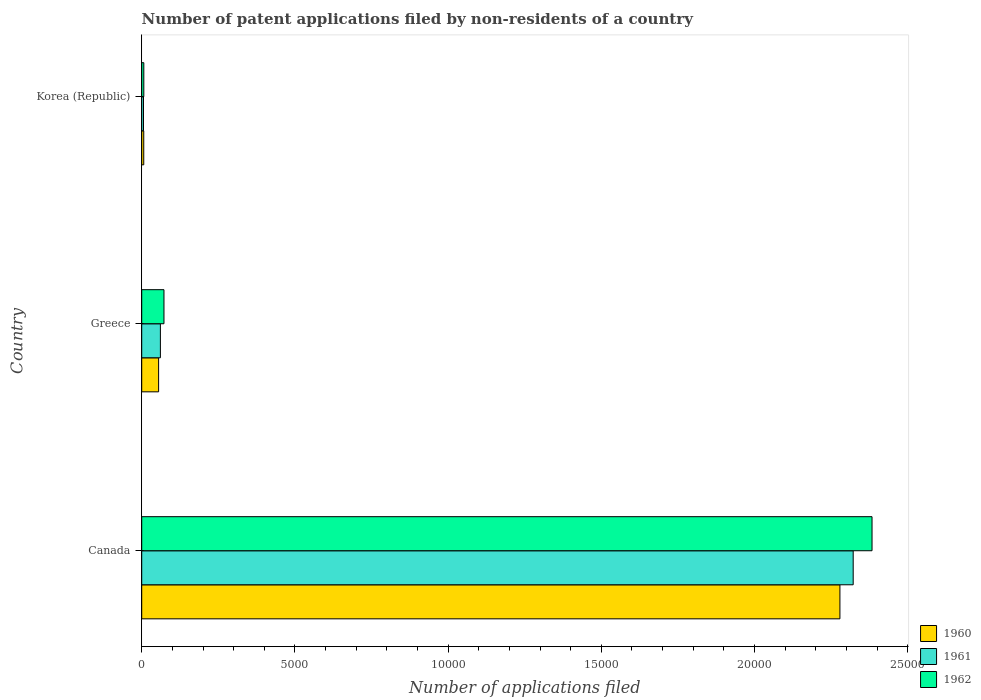Are the number of bars on each tick of the Y-axis equal?
Provide a short and direct response. Yes. How many bars are there on the 1st tick from the top?
Offer a very short reply. 3. Across all countries, what is the maximum number of applications filed in 1962?
Make the answer very short. 2.38e+04. In which country was the number of applications filed in 1960 minimum?
Make the answer very short. Korea (Republic). What is the total number of applications filed in 1960 in the graph?
Keep it short and to the point. 2.34e+04. What is the difference between the number of applications filed in 1962 in Canada and that in Greece?
Offer a terse response. 2.31e+04. What is the difference between the number of applications filed in 1960 in Greece and the number of applications filed in 1961 in Canada?
Keep it short and to the point. -2.27e+04. What is the average number of applications filed in 1961 per country?
Give a very brief answer. 7962. What is the difference between the number of applications filed in 1961 and number of applications filed in 1962 in Canada?
Keep it short and to the point. -615. In how many countries, is the number of applications filed in 1961 greater than 8000 ?
Offer a very short reply. 1. What is the ratio of the number of applications filed in 1960 in Canada to that in Greece?
Make the answer very short. 41.35. What is the difference between the highest and the second highest number of applications filed in 1960?
Provide a short and direct response. 2.22e+04. What is the difference between the highest and the lowest number of applications filed in 1961?
Ensure brevity in your answer.  2.32e+04. In how many countries, is the number of applications filed in 1960 greater than the average number of applications filed in 1960 taken over all countries?
Provide a short and direct response. 1. Is the sum of the number of applications filed in 1962 in Canada and Korea (Republic) greater than the maximum number of applications filed in 1960 across all countries?
Give a very brief answer. Yes. What does the 1st bar from the bottom in Greece represents?
Offer a very short reply. 1960. Is it the case that in every country, the sum of the number of applications filed in 1962 and number of applications filed in 1961 is greater than the number of applications filed in 1960?
Provide a succinct answer. Yes. Are all the bars in the graph horizontal?
Your answer should be compact. Yes. How many countries are there in the graph?
Your answer should be very brief. 3. Are the values on the major ticks of X-axis written in scientific E-notation?
Your answer should be compact. No. Does the graph contain any zero values?
Provide a short and direct response. No. How many legend labels are there?
Keep it short and to the point. 3. What is the title of the graph?
Your response must be concise. Number of patent applications filed by non-residents of a country. What is the label or title of the X-axis?
Make the answer very short. Number of applications filed. What is the label or title of the Y-axis?
Give a very brief answer. Country. What is the Number of applications filed of 1960 in Canada?
Your response must be concise. 2.28e+04. What is the Number of applications filed in 1961 in Canada?
Offer a terse response. 2.32e+04. What is the Number of applications filed in 1962 in Canada?
Your response must be concise. 2.38e+04. What is the Number of applications filed in 1960 in Greece?
Your response must be concise. 551. What is the Number of applications filed of 1961 in Greece?
Provide a short and direct response. 609. What is the Number of applications filed in 1962 in Greece?
Offer a terse response. 726. What is the Number of applications filed of 1960 in Korea (Republic)?
Your answer should be compact. 66. What is the Number of applications filed of 1961 in Korea (Republic)?
Make the answer very short. 58. Across all countries, what is the maximum Number of applications filed of 1960?
Make the answer very short. 2.28e+04. Across all countries, what is the maximum Number of applications filed of 1961?
Your response must be concise. 2.32e+04. Across all countries, what is the maximum Number of applications filed of 1962?
Your response must be concise. 2.38e+04. Across all countries, what is the minimum Number of applications filed of 1960?
Your response must be concise. 66. What is the total Number of applications filed in 1960 in the graph?
Give a very brief answer. 2.34e+04. What is the total Number of applications filed of 1961 in the graph?
Give a very brief answer. 2.39e+04. What is the total Number of applications filed of 1962 in the graph?
Ensure brevity in your answer.  2.46e+04. What is the difference between the Number of applications filed in 1960 in Canada and that in Greece?
Your response must be concise. 2.22e+04. What is the difference between the Number of applications filed of 1961 in Canada and that in Greece?
Provide a succinct answer. 2.26e+04. What is the difference between the Number of applications filed in 1962 in Canada and that in Greece?
Make the answer very short. 2.31e+04. What is the difference between the Number of applications filed in 1960 in Canada and that in Korea (Republic)?
Ensure brevity in your answer.  2.27e+04. What is the difference between the Number of applications filed in 1961 in Canada and that in Korea (Republic)?
Offer a very short reply. 2.32e+04. What is the difference between the Number of applications filed of 1962 in Canada and that in Korea (Republic)?
Provide a short and direct response. 2.38e+04. What is the difference between the Number of applications filed of 1960 in Greece and that in Korea (Republic)?
Your answer should be very brief. 485. What is the difference between the Number of applications filed in 1961 in Greece and that in Korea (Republic)?
Provide a succinct answer. 551. What is the difference between the Number of applications filed in 1962 in Greece and that in Korea (Republic)?
Provide a short and direct response. 658. What is the difference between the Number of applications filed in 1960 in Canada and the Number of applications filed in 1961 in Greece?
Provide a succinct answer. 2.22e+04. What is the difference between the Number of applications filed in 1960 in Canada and the Number of applications filed in 1962 in Greece?
Keep it short and to the point. 2.21e+04. What is the difference between the Number of applications filed in 1961 in Canada and the Number of applications filed in 1962 in Greece?
Keep it short and to the point. 2.25e+04. What is the difference between the Number of applications filed in 1960 in Canada and the Number of applications filed in 1961 in Korea (Republic)?
Ensure brevity in your answer.  2.27e+04. What is the difference between the Number of applications filed of 1960 in Canada and the Number of applications filed of 1962 in Korea (Republic)?
Offer a very short reply. 2.27e+04. What is the difference between the Number of applications filed of 1961 in Canada and the Number of applications filed of 1962 in Korea (Republic)?
Ensure brevity in your answer.  2.32e+04. What is the difference between the Number of applications filed of 1960 in Greece and the Number of applications filed of 1961 in Korea (Republic)?
Keep it short and to the point. 493. What is the difference between the Number of applications filed of 1960 in Greece and the Number of applications filed of 1962 in Korea (Republic)?
Provide a succinct answer. 483. What is the difference between the Number of applications filed of 1961 in Greece and the Number of applications filed of 1962 in Korea (Republic)?
Provide a succinct answer. 541. What is the average Number of applications filed of 1960 per country?
Your response must be concise. 7801. What is the average Number of applications filed of 1961 per country?
Ensure brevity in your answer.  7962. What is the average Number of applications filed in 1962 per country?
Provide a short and direct response. 8209.33. What is the difference between the Number of applications filed in 1960 and Number of applications filed in 1961 in Canada?
Offer a terse response. -433. What is the difference between the Number of applications filed of 1960 and Number of applications filed of 1962 in Canada?
Keep it short and to the point. -1048. What is the difference between the Number of applications filed in 1961 and Number of applications filed in 1962 in Canada?
Offer a very short reply. -615. What is the difference between the Number of applications filed in 1960 and Number of applications filed in 1961 in Greece?
Your response must be concise. -58. What is the difference between the Number of applications filed in 1960 and Number of applications filed in 1962 in Greece?
Ensure brevity in your answer.  -175. What is the difference between the Number of applications filed in 1961 and Number of applications filed in 1962 in Greece?
Your answer should be very brief. -117. What is the difference between the Number of applications filed of 1960 and Number of applications filed of 1961 in Korea (Republic)?
Your response must be concise. 8. What is the difference between the Number of applications filed of 1960 and Number of applications filed of 1962 in Korea (Republic)?
Give a very brief answer. -2. What is the difference between the Number of applications filed of 1961 and Number of applications filed of 1962 in Korea (Republic)?
Your answer should be very brief. -10. What is the ratio of the Number of applications filed in 1960 in Canada to that in Greece?
Your answer should be compact. 41.35. What is the ratio of the Number of applications filed in 1961 in Canada to that in Greece?
Give a very brief answer. 38.13. What is the ratio of the Number of applications filed of 1962 in Canada to that in Greece?
Your response must be concise. 32.83. What is the ratio of the Number of applications filed of 1960 in Canada to that in Korea (Republic)?
Give a very brief answer. 345.24. What is the ratio of the Number of applications filed of 1961 in Canada to that in Korea (Republic)?
Your response must be concise. 400.33. What is the ratio of the Number of applications filed in 1962 in Canada to that in Korea (Republic)?
Offer a very short reply. 350.5. What is the ratio of the Number of applications filed of 1960 in Greece to that in Korea (Republic)?
Give a very brief answer. 8.35. What is the ratio of the Number of applications filed of 1962 in Greece to that in Korea (Republic)?
Keep it short and to the point. 10.68. What is the difference between the highest and the second highest Number of applications filed of 1960?
Your answer should be very brief. 2.22e+04. What is the difference between the highest and the second highest Number of applications filed of 1961?
Your answer should be compact. 2.26e+04. What is the difference between the highest and the second highest Number of applications filed of 1962?
Ensure brevity in your answer.  2.31e+04. What is the difference between the highest and the lowest Number of applications filed in 1960?
Provide a short and direct response. 2.27e+04. What is the difference between the highest and the lowest Number of applications filed in 1961?
Ensure brevity in your answer.  2.32e+04. What is the difference between the highest and the lowest Number of applications filed in 1962?
Ensure brevity in your answer.  2.38e+04. 